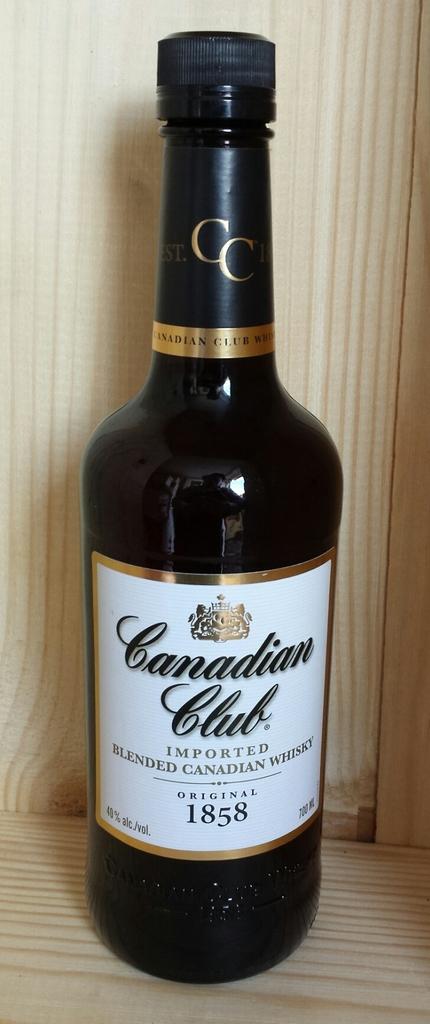What year is this bottle from?
Provide a succinct answer. 1858. What club is this from?
Make the answer very short. Canadian. 